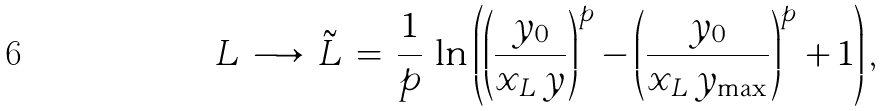Convert formula to latex. <formula><loc_0><loc_0><loc_500><loc_500>L \, \longrightarrow \, \tilde { L } \, = \, \frac { 1 } { p } \, \ln \left ( \left ( \frac { y _ { 0 } } { x _ { L } \, y } \right ) ^ { p } - \left ( \frac { y _ { 0 } } { x _ { L } \, y _ { \max } } \right ) ^ { p } + 1 \right ) ,</formula> 